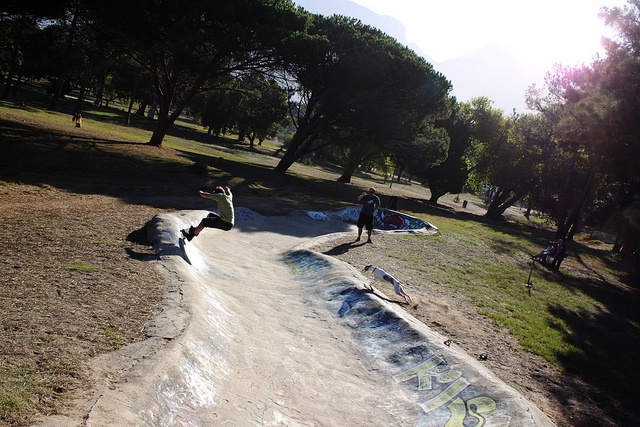Describe the objects in this image and their specific colors. I can see people in black, white, gray, and darkgray tones, people in black, gray, maroon, and darkgray tones, dog in black, gray, and darkgray tones, people in black, gray, and maroon tones, and people in black, gray, navy, and maroon tones in this image. 